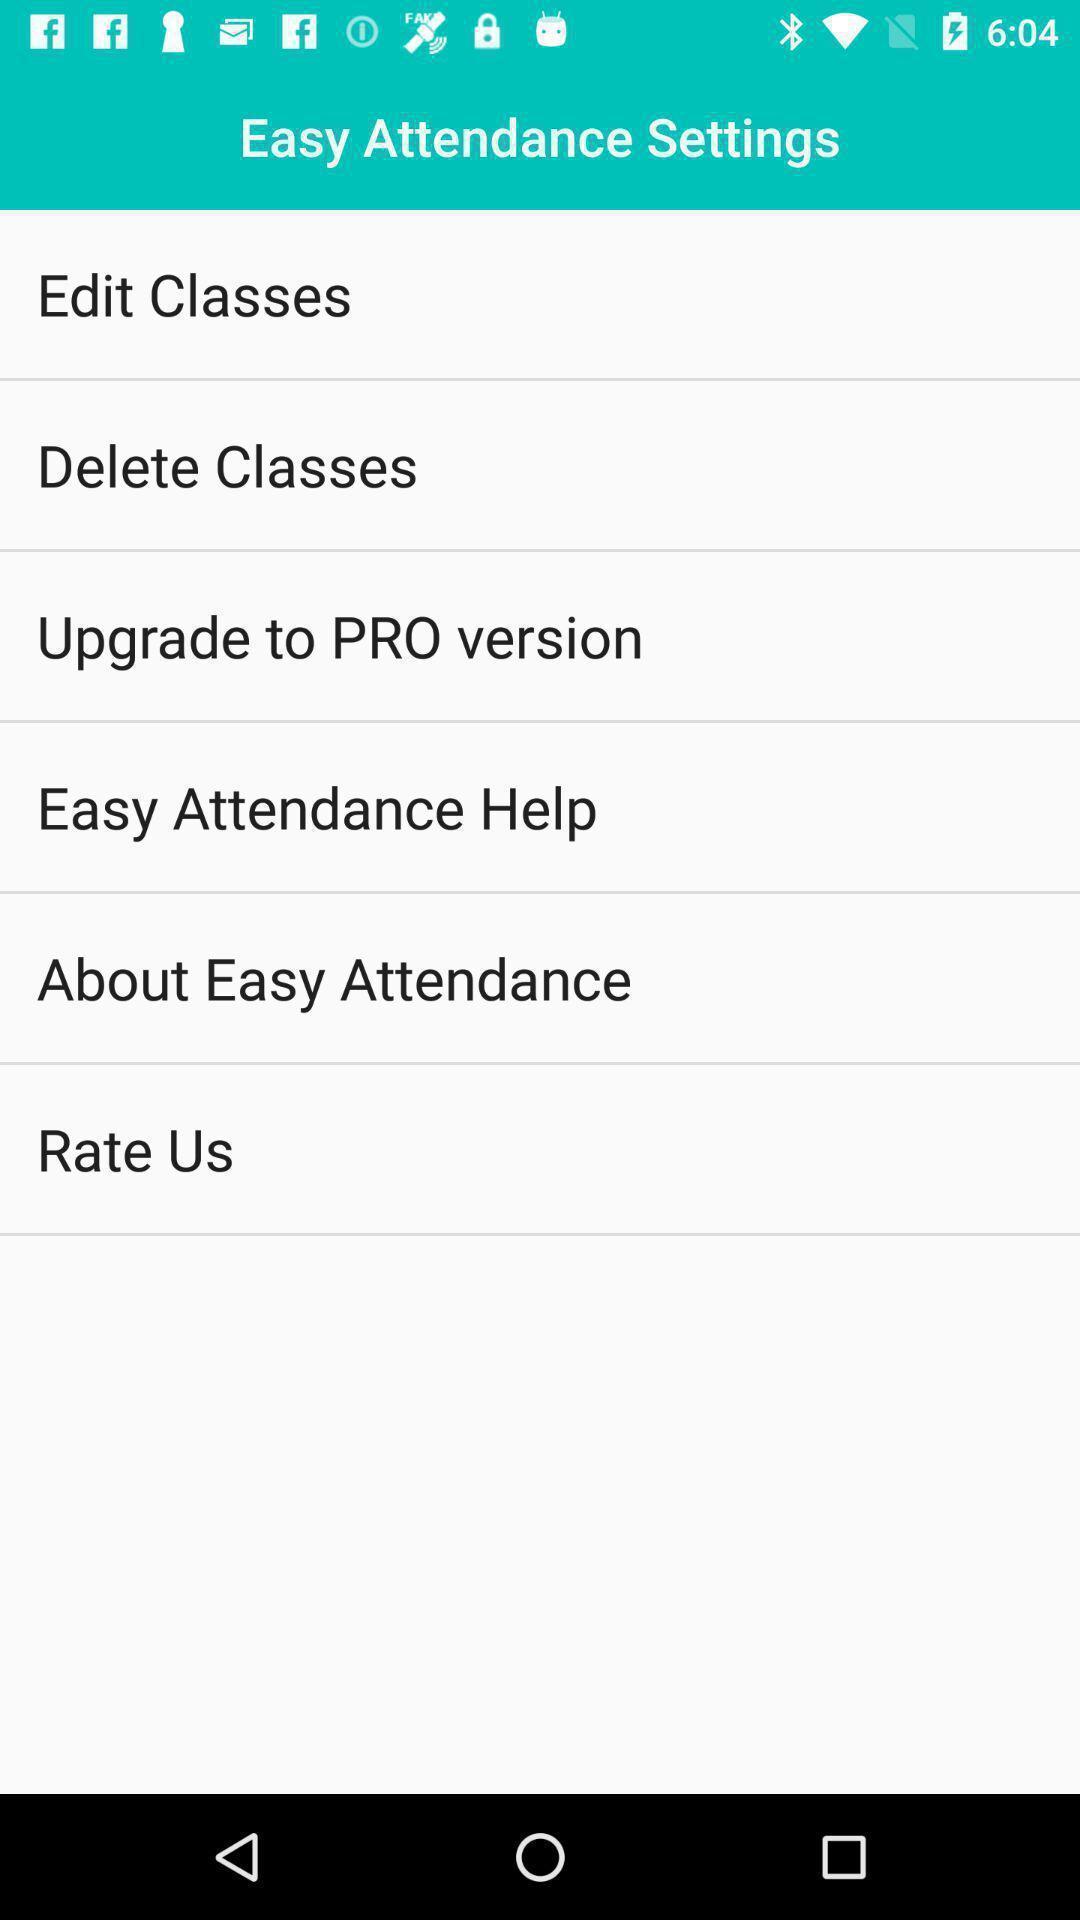What can you discern from this picture? Settings page. 